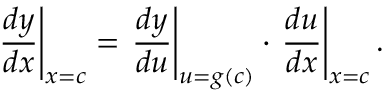<formula> <loc_0><loc_0><loc_500><loc_500>{ \frac { d y } { d x } } \right | _ { x = c } = { \frac { d y } { d u } } \right | _ { u = g ( c ) } \cdot { \frac { d u } { d x } } \right | _ { x = c } .</formula> 